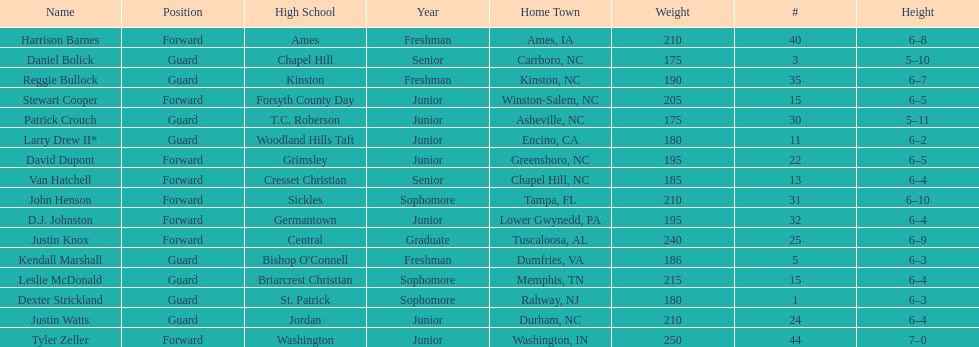Can you parse all the data within this table? {'header': ['Name', 'Position', 'High School', 'Year', 'Home Town', 'Weight', '#', 'Height'], 'rows': [['Harrison Barnes', 'Forward', 'Ames', 'Freshman', 'Ames, IA', '210', '40', '6–8'], ['Daniel Bolick', 'Guard', 'Chapel Hill', 'Senior', 'Carrboro, NC', '175', '3', '5–10'], ['Reggie Bullock', 'Guard', 'Kinston', 'Freshman', 'Kinston, NC', '190', '35', '6–7'], ['Stewart Cooper', 'Forward', 'Forsyth County Day', 'Junior', 'Winston-Salem, NC', '205', '15', '6–5'], ['Patrick Crouch', 'Guard', 'T.C. Roberson', 'Junior', 'Asheville, NC', '175', '30', '5–11'], ['Larry Drew II*', 'Guard', 'Woodland Hills Taft', 'Junior', 'Encino, CA', '180', '11', '6–2'], ['David Dupont', 'Forward', 'Grimsley', 'Junior', 'Greensboro, NC', '195', '22', '6–5'], ['Van Hatchell', 'Forward', 'Cresset Christian', 'Senior', 'Chapel Hill, NC', '185', '13', '6–4'], ['John Henson', 'Forward', 'Sickles', 'Sophomore', 'Tampa, FL', '210', '31', '6–10'], ['D.J. Johnston', 'Forward', 'Germantown', 'Junior', 'Lower Gwynedd, PA', '195', '32', '6–4'], ['Justin Knox', 'Forward', 'Central', 'Graduate', 'Tuscaloosa, AL', '240', '25', '6–9'], ['Kendall Marshall', 'Guard', "Bishop O'Connell", 'Freshman', 'Dumfries, VA', '186', '5', '6–3'], ['Leslie McDonald', 'Guard', 'Briarcrest Christian', 'Sophomore', 'Memphis, TN', '215', '15', '6–4'], ['Dexter Strickland', 'Guard', 'St. Patrick', 'Sophomore', 'Rahway, NJ', '180', '1', '6–3'], ['Justin Watts', 'Guard', 'Jordan', 'Junior', 'Durham, NC', '210', '24', '6–4'], ['Tyler Zeller', 'Forward', 'Washington', 'Junior', 'Washington, IN', '250', '44', '7–0']]} How many players play a position other than guard? 8. 